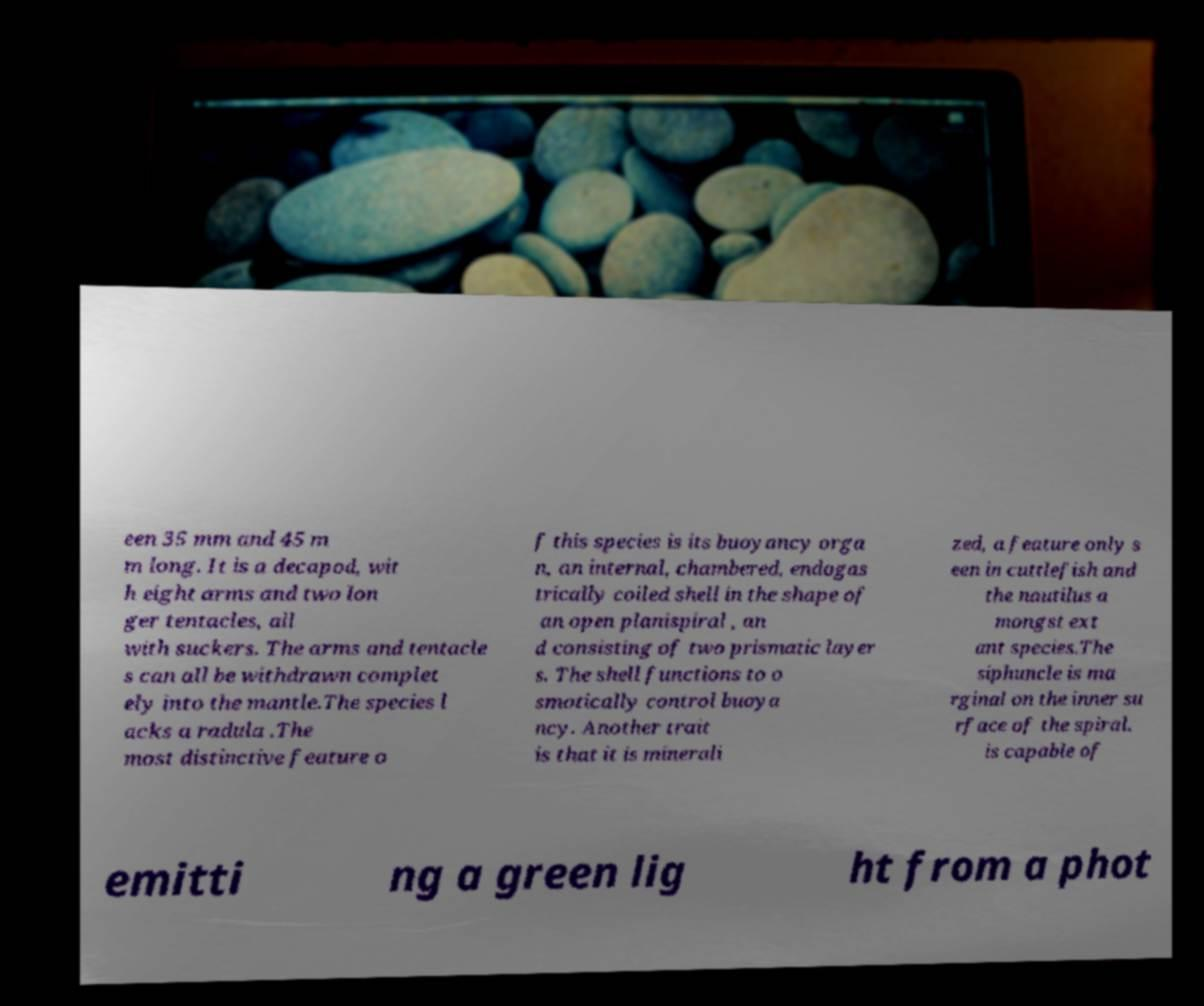I need the written content from this picture converted into text. Can you do that? een 35 mm and 45 m m long. It is a decapod, wit h eight arms and two lon ger tentacles, all with suckers. The arms and tentacle s can all be withdrawn complet ely into the mantle.The species l acks a radula .The most distinctive feature o f this species is its buoyancy orga n, an internal, chambered, endogas trically coiled shell in the shape of an open planispiral , an d consisting of two prismatic layer s. The shell functions to o smotically control buoya ncy. Another trait is that it is minerali zed, a feature only s een in cuttlefish and the nautilus a mongst ext ant species.The siphuncle is ma rginal on the inner su rface of the spiral. is capable of emitti ng a green lig ht from a phot 